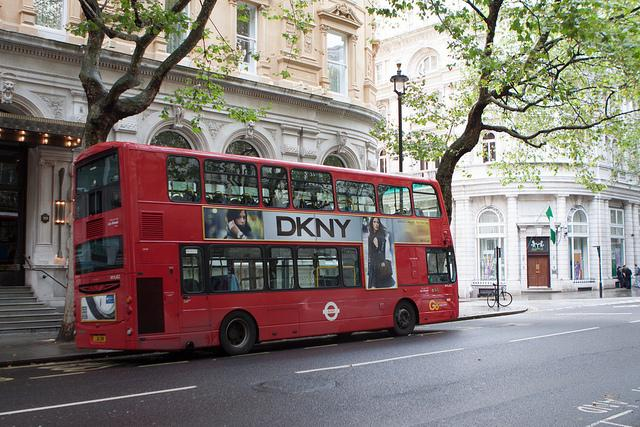What state is the company from whose logo appears on the bus? new york 